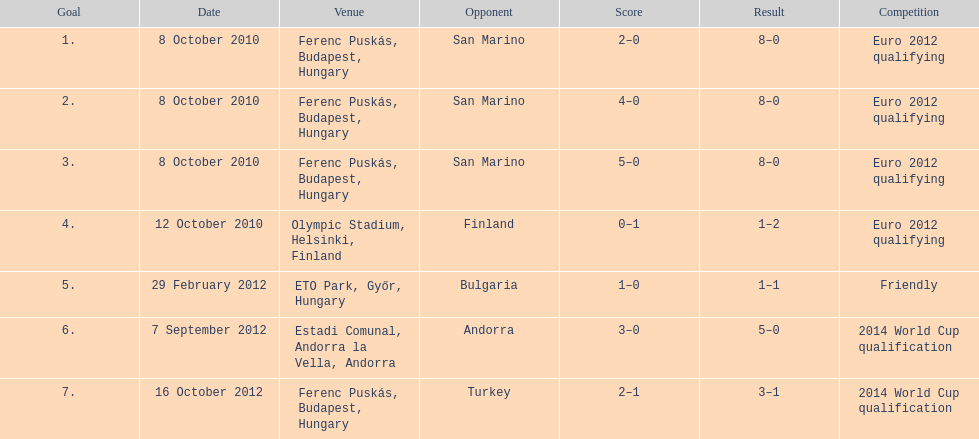Szalai scored all but one of his international goals in either euro 2012 qualifying or what other level of play? 2014 World Cup qualification. 